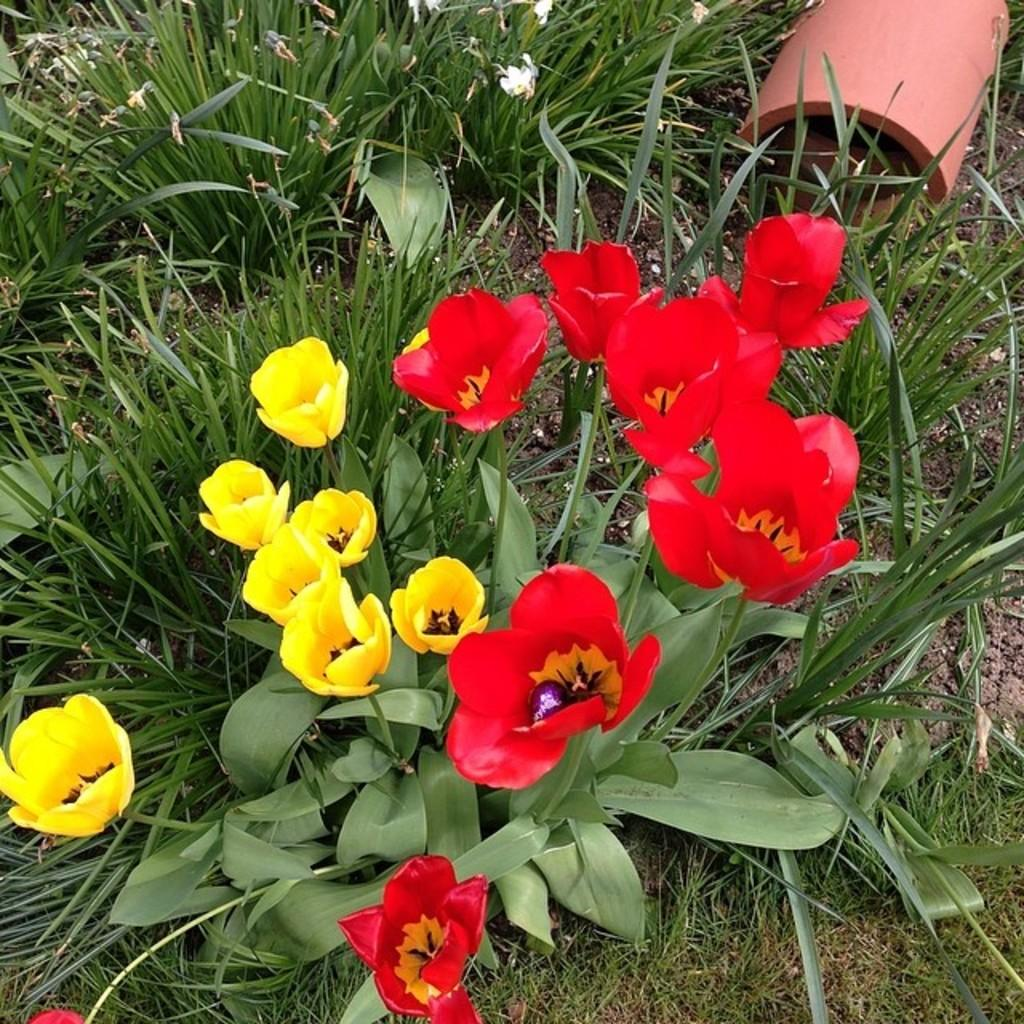What type of living organisms can be seen in the image? There are flowers and plants in the image. Can you describe the plants in the image? The plants in the image are not specified, but they are present alongside the flowers. How many children are playing with the ear in the image? There are no children or ears present in the image; it only features flowers and plants. 